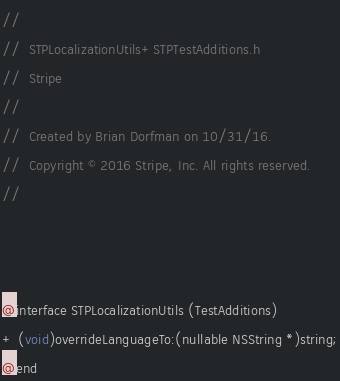<code> <loc_0><loc_0><loc_500><loc_500><_C_>//
//  STPLocalizationUtils+STPTestAdditions.h
//  Stripe
//
//  Created by Brian Dorfman on 10/31/16.
//  Copyright © 2016 Stripe, Inc. All rights reserved.
//



@interface STPLocalizationUtils (TestAdditions)
+ (void)overrideLanguageTo:(nullable NSString *)string;
@end
</code> 